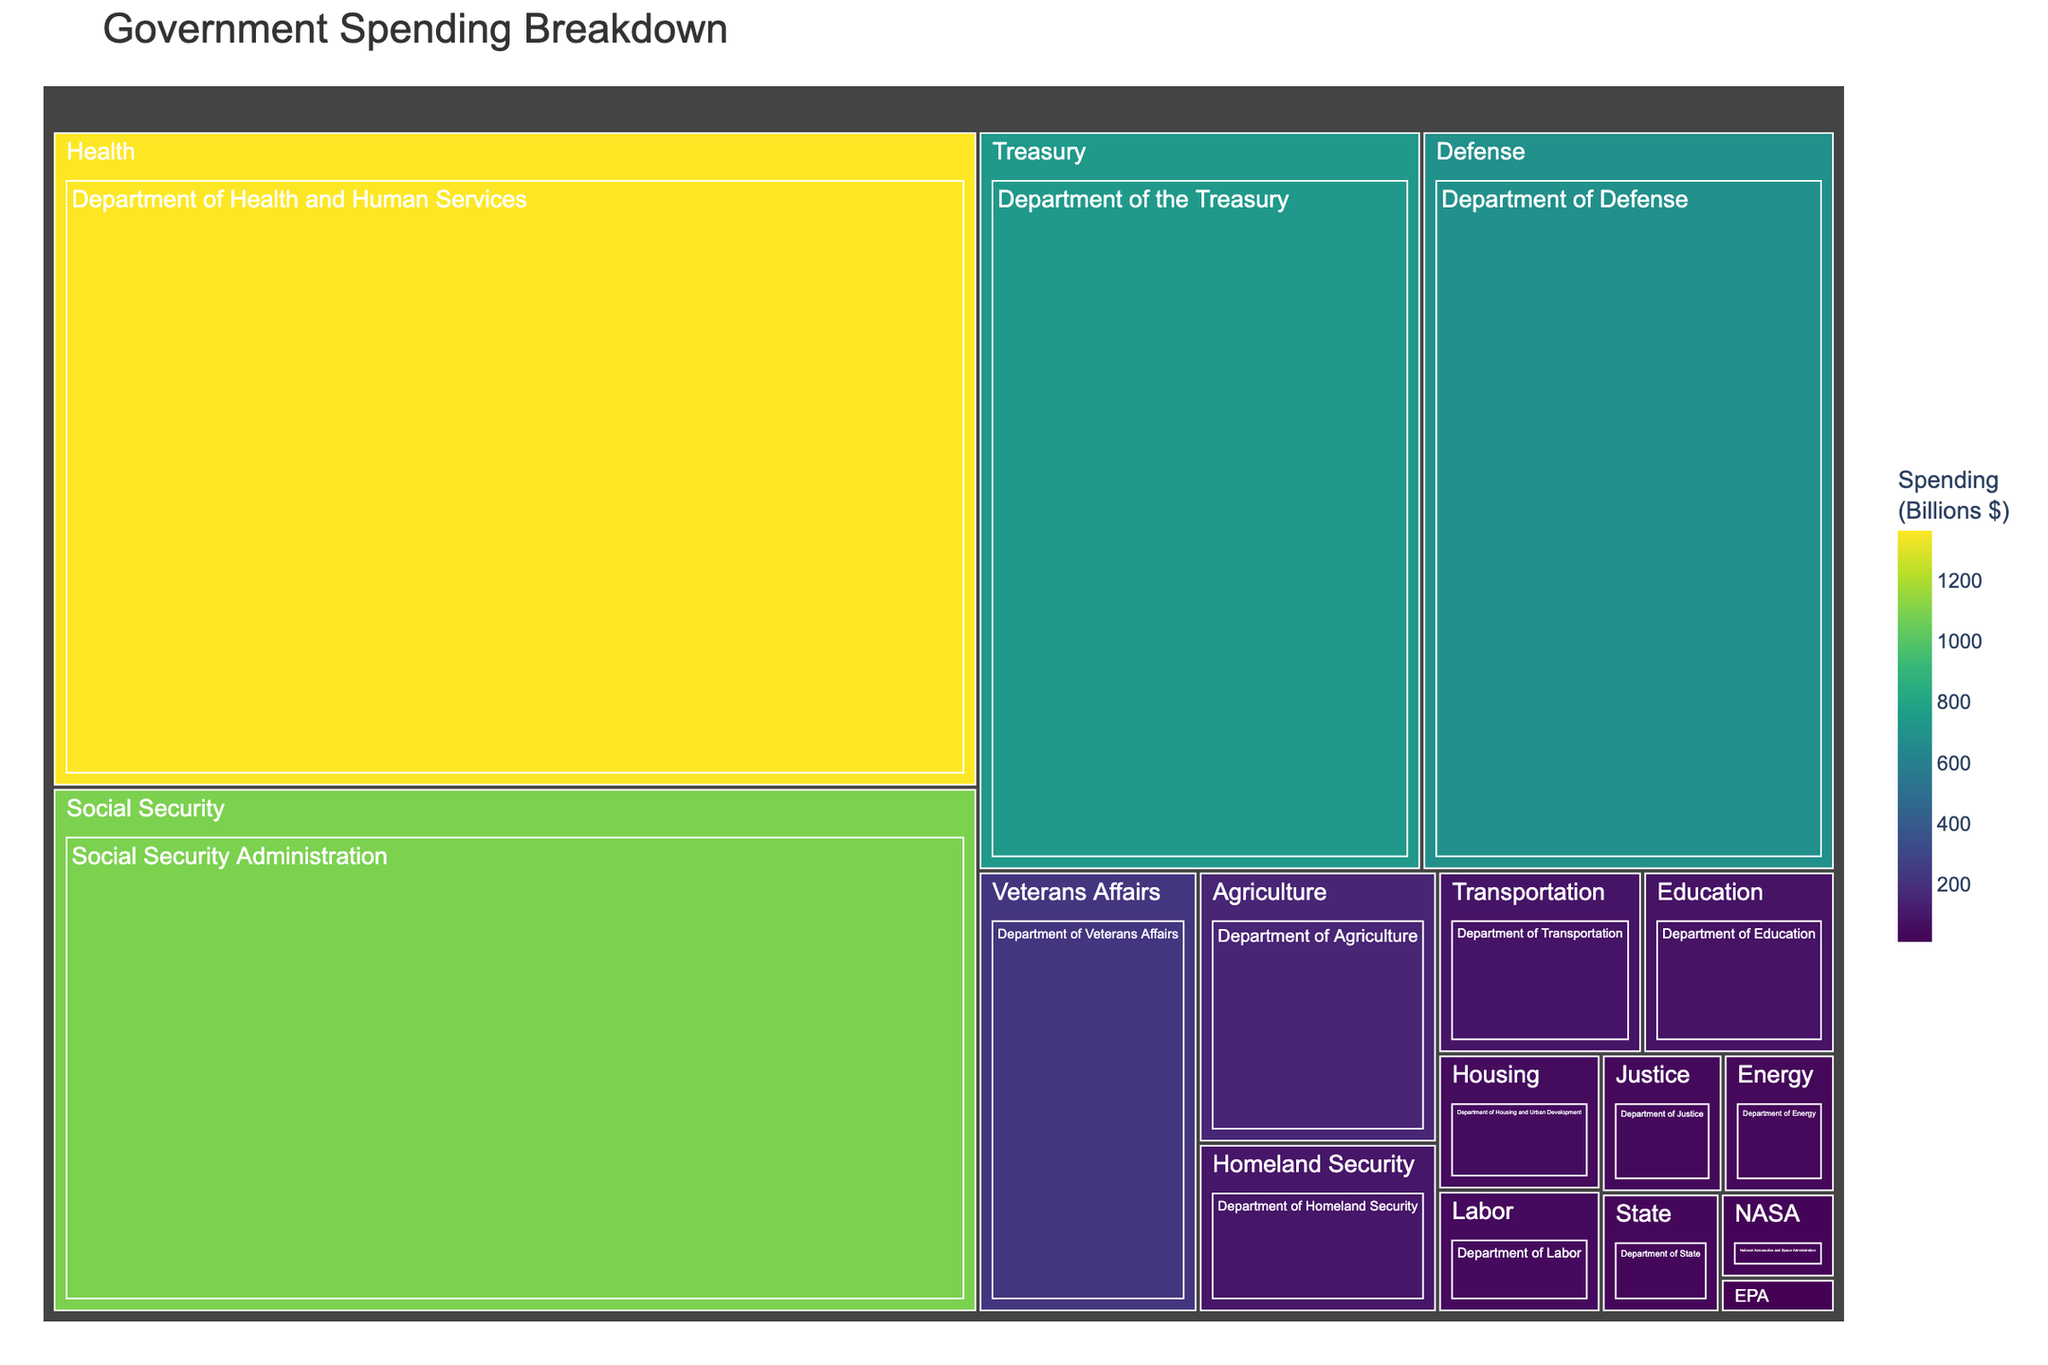what is the title of the treemap? The title of the treemap is displayed at the top of the figure.
Answer: Government Spending Breakdown Which department has the highest spending? The department with the highest spending is represented by the largest area on the treemap.
Answer: Department of Health and Human Services Which two departments have the closest spending amounts? To determine this, look for departments with similarly sized areas corresponding to their spending values.
Answer: Department of Transportation and Department of Education What is the total spending of the Department of Defense and the Department of the Treasury? Add the spending of both departments: $686 billion (Defense) + $736 billion (Treasury) = $1422 billion.
Answer: $1422 billion How does the spending on Social Security compare to the spending on Defense? Compare the size of the areas representing Social Security and Defense spending. Social Security has a larger area.
Answer: Social Security spending is higher What is the average spending across all departments? To find the average, sum all the spending amounts and divide by the number of departments: (686 + 1362 + 1090 + 79 + 218 + 84 + 146 + 50 + 35 + 32 + 38 + 45 + 91 + 736 + 22 + 9) / 16 = 3723 / 16 = 232.69 billion.
Answer: 232.69 billion Which department's spending is closest to $100 billion? Locate the area closest in size to a value of approximately $100 billion.
Answer: Department of Homeland Security How does the spending on Veterans Affairs compare to that on Education? Compare the sizes of the two areas; Veterans Affairs has a larger area.
Answer: Veterans Affairs spending is higher What are the three departments with the smallest spending? Identify the three smallest areas on the treemap.
Answer: Environmental Protection Agency, National Aeronautics and Space Administration, Department of State If combined, would the total spending of the Department of Agriculture and Department of Energy exceed the spending of the Department of Defense? Combine the values: $146 billion (Agriculture) + $35 billion (Energy) = $181 billion. Compare with $686 billion (Defense).
Answer: No 